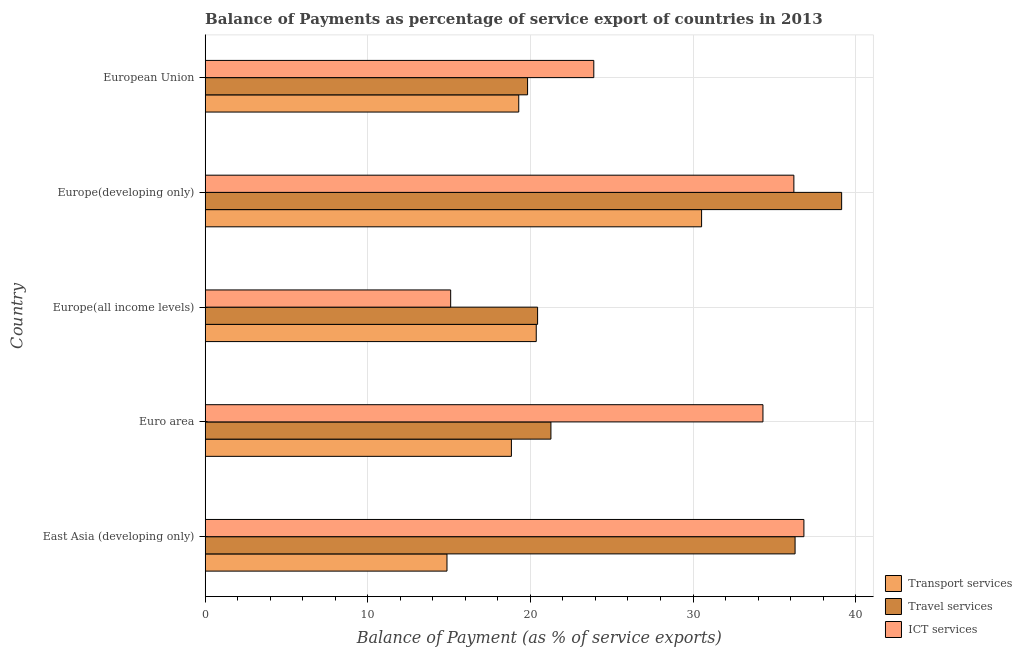Are the number of bars on each tick of the Y-axis equal?
Ensure brevity in your answer.  Yes. How many bars are there on the 1st tick from the top?
Make the answer very short. 3. How many bars are there on the 5th tick from the bottom?
Give a very brief answer. 3. What is the label of the 1st group of bars from the top?
Your answer should be very brief. European Union. What is the balance of payment of ict services in Europe(all income levels)?
Make the answer very short. 15.1. Across all countries, what is the maximum balance of payment of travel services?
Your response must be concise. 39.14. Across all countries, what is the minimum balance of payment of ict services?
Provide a succinct answer. 15.1. In which country was the balance of payment of ict services maximum?
Your response must be concise. East Asia (developing only). In which country was the balance of payment of travel services minimum?
Give a very brief answer. European Union. What is the total balance of payment of ict services in the graph?
Make the answer very short. 146.32. What is the difference between the balance of payment of ict services in Europe(developing only) and that in European Union?
Make the answer very short. 12.3. What is the difference between the balance of payment of travel services in Europe(all income levels) and the balance of payment of ict services in East Asia (developing only)?
Give a very brief answer. -16.38. What is the average balance of payment of ict services per country?
Provide a short and direct response. 29.26. What is the difference between the balance of payment of ict services and balance of payment of travel services in European Union?
Your response must be concise. 4.07. What is the ratio of the balance of payment of ict services in Euro area to that in Europe(developing only)?
Ensure brevity in your answer.  0.95. Is the difference between the balance of payment of ict services in East Asia (developing only) and Euro area greater than the difference between the balance of payment of travel services in East Asia (developing only) and Euro area?
Give a very brief answer. No. What is the difference between the highest and the second highest balance of payment of transport services?
Give a very brief answer. 10.17. What is the difference between the highest and the lowest balance of payment of ict services?
Provide a succinct answer. 21.72. In how many countries, is the balance of payment of ict services greater than the average balance of payment of ict services taken over all countries?
Your answer should be compact. 3. Is the sum of the balance of payment of ict services in East Asia (developing only) and Europe(developing only) greater than the maximum balance of payment of travel services across all countries?
Your answer should be very brief. Yes. What does the 1st bar from the top in East Asia (developing only) represents?
Offer a very short reply. ICT services. What does the 2nd bar from the bottom in European Union represents?
Your answer should be compact. Travel services. Is it the case that in every country, the sum of the balance of payment of transport services and balance of payment of travel services is greater than the balance of payment of ict services?
Your response must be concise. Yes. Are all the bars in the graph horizontal?
Provide a succinct answer. Yes. What is the difference between two consecutive major ticks on the X-axis?
Ensure brevity in your answer.  10. Where does the legend appear in the graph?
Your answer should be compact. Bottom right. How many legend labels are there?
Provide a short and direct response. 3. What is the title of the graph?
Provide a short and direct response. Balance of Payments as percentage of service export of countries in 2013. What is the label or title of the X-axis?
Provide a short and direct response. Balance of Payment (as % of service exports). What is the label or title of the Y-axis?
Offer a terse response. Country. What is the Balance of Payment (as % of service exports) in Transport services in East Asia (developing only)?
Your answer should be compact. 14.87. What is the Balance of Payment (as % of service exports) of Travel services in East Asia (developing only)?
Provide a short and direct response. 36.28. What is the Balance of Payment (as % of service exports) in ICT services in East Asia (developing only)?
Your response must be concise. 36.82. What is the Balance of Payment (as % of service exports) in Transport services in Euro area?
Give a very brief answer. 18.83. What is the Balance of Payment (as % of service exports) in Travel services in Euro area?
Provide a succinct answer. 21.26. What is the Balance of Payment (as % of service exports) in ICT services in Euro area?
Your answer should be very brief. 34.3. What is the Balance of Payment (as % of service exports) in Transport services in Europe(all income levels)?
Ensure brevity in your answer.  20.36. What is the Balance of Payment (as % of service exports) in Travel services in Europe(all income levels)?
Provide a succinct answer. 20.44. What is the Balance of Payment (as % of service exports) in ICT services in Europe(all income levels)?
Offer a very short reply. 15.1. What is the Balance of Payment (as % of service exports) in Transport services in Europe(developing only)?
Offer a terse response. 30.53. What is the Balance of Payment (as % of service exports) of Travel services in Europe(developing only)?
Offer a very short reply. 39.14. What is the Balance of Payment (as % of service exports) of ICT services in Europe(developing only)?
Provide a succinct answer. 36.2. What is the Balance of Payment (as % of service exports) of Transport services in European Union?
Provide a succinct answer. 19.28. What is the Balance of Payment (as % of service exports) of Travel services in European Union?
Provide a short and direct response. 19.83. What is the Balance of Payment (as % of service exports) in ICT services in European Union?
Make the answer very short. 23.9. Across all countries, what is the maximum Balance of Payment (as % of service exports) in Transport services?
Provide a short and direct response. 30.53. Across all countries, what is the maximum Balance of Payment (as % of service exports) of Travel services?
Your response must be concise. 39.14. Across all countries, what is the maximum Balance of Payment (as % of service exports) of ICT services?
Provide a short and direct response. 36.82. Across all countries, what is the minimum Balance of Payment (as % of service exports) in Transport services?
Give a very brief answer. 14.87. Across all countries, what is the minimum Balance of Payment (as % of service exports) in Travel services?
Your answer should be compact. 19.83. Across all countries, what is the minimum Balance of Payment (as % of service exports) of ICT services?
Your response must be concise. 15.1. What is the total Balance of Payment (as % of service exports) in Transport services in the graph?
Your response must be concise. 103.87. What is the total Balance of Payment (as % of service exports) of Travel services in the graph?
Offer a terse response. 136.95. What is the total Balance of Payment (as % of service exports) of ICT services in the graph?
Make the answer very short. 146.32. What is the difference between the Balance of Payment (as % of service exports) of Transport services in East Asia (developing only) and that in Euro area?
Provide a short and direct response. -3.96. What is the difference between the Balance of Payment (as % of service exports) in Travel services in East Asia (developing only) and that in Euro area?
Keep it short and to the point. 15.02. What is the difference between the Balance of Payment (as % of service exports) of ICT services in East Asia (developing only) and that in Euro area?
Ensure brevity in your answer.  2.52. What is the difference between the Balance of Payment (as % of service exports) of Transport services in East Asia (developing only) and that in Europe(all income levels)?
Make the answer very short. -5.49. What is the difference between the Balance of Payment (as % of service exports) of Travel services in East Asia (developing only) and that in Europe(all income levels)?
Offer a very short reply. 15.83. What is the difference between the Balance of Payment (as % of service exports) in ICT services in East Asia (developing only) and that in Europe(all income levels)?
Ensure brevity in your answer.  21.72. What is the difference between the Balance of Payment (as % of service exports) in Transport services in East Asia (developing only) and that in Europe(developing only)?
Provide a succinct answer. -15.66. What is the difference between the Balance of Payment (as % of service exports) of Travel services in East Asia (developing only) and that in Europe(developing only)?
Offer a terse response. -2.86. What is the difference between the Balance of Payment (as % of service exports) of ICT services in East Asia (developing only) and that in Europe(developing only)?
Give a very brief answer. 0.62. What is the difference between the Balance of Payment (as % of service exports) of Transport services in East Asia (developing only) and that in European Union?
Keep it short and to the point. -4.41. What is the difference between the Balance of Payment (as % of service exports) of Travel services in East Asia (developing only) and that in European Union?
Provide a short and direct response. 16.45. What is the difference between the Balance of Payment (as % of service exports) in ICT services in East Asia (developing only) and that in European Union?
Keep it short and to the point. 12.92. What is the difference between the Balance of Payment (as % of service exports) of Transport services in Euro area and that in Europe(all income levels)?
Your answer should be compact. -1.53. What is the difference between the Balance of Payment (as % of service exports) of Travel services in Euro area and that in Europe(all income levels)?
Provide a short and direct response. 0.82. What is the difference between the Balance of Payment (as % of service exports) in ICT services in Euro area and that in Europe(all income levels)?
Provide a short and direct response. 19.2. What is the difference between the Balance of Payment (as % of service exports) of Transport services in Euro area and that in Europe(developing only)?
Keep it short and to the point. -11.7. What is the difference between the Balance of Payment (as % of service exports) in Travel services in Euro area and that in Europe(developing only)?
Ensure brevity in your answer.  -17.88. What is the difference between the Balance of Payment (as % of service exports) of ICT services in Euro area and that in Europe(developing only)?
Ensure brevity in your answer.  -1.9. What is the difference between the Balance of Payment (as % of service exports) of Transport services in Euro area and that in European Union?
Make the answer very short. -0.45. What is the difference between the Balance of Payment (as % of service exports) of Travel services in Euro area and that in European Union?
Ensure brevity in your answer.  1.44. What is the difference between the Balance of Payment (as % of service exports) in ICT services in Euro area and that in European Union?
Keep it short and to the point. 10.4. What is the difference between the Balance of Payment (as % of service exports) in Transport services in Europe(all income levels) and that in Europe(developing only)?
Keep it short and to the point. -10.17. What is the difference between the Balance of Payment (as % of service exports) of Travel services in Europe(all income levels) and that in Europe(developing only)?
Keep it short and to the point. -18.7. What is the difference between the Balance of Payment (as % of service exports) in ICT services in Europe(all income levels) and that in Europe(developing only)?
Your response must be concise. -21.11. What is the difference between the Balance of Payment (as % of service exports) in Transport services in Europe(all income levels) and that in European Union?
Offer a very short reply. 1.08. What is the difference between the Balance of Payment (as % of service exports) in Travel services in Europe(all income levels) and that in European Union?
Keep it short and to the point. 0.62. What is the difference between the Balance of Payment (as % of service exports) of ICT services in Europe(all income levels) and that in European Union?
Offer a very short reply. -8.8. What is the difference between the Balance of Payment (as % of service exports) in Transport services in Europe(developing only) and that in European Union?
Offer a terse response. 11.24. What is the difference between the Balance of Payment (as % of service exports) of Travel services in Europe(developing only) and that in European Union?
Keep it short and to the point. 19.31. What is the difference between the Balance of Payment (as % of service exports) of ICT services in Europe(developing only) and that in European Union?
Ensure brevity in your answer.  12.3. What is the difference between the Balance of Payment (as % of service exports) of Transport services in East Asia (developing only) and the Balance of Payment (as % of service exports) of Travel services in Euro area?
Provide a succinct answer. -6.39. What is the difference between the Balance of Payment (as % of service exports) in Transport services in East Asia (developing only) and the Balance of Payment (as % of service exports) in ICT services in Euro area?
Offer a very short reply. -19.43. What is the difference between the Balance of Payment (as % of service exports) in Travel services in East Asia (developing only) and the Balance of Payment (as % of service exports) in ICT services in Euro area?
Your response must be concise. 1.98. What is the difference between the Balance of Payment (as % of service exports) in Transport services in East Asia (developing only) and the Balance of Payment (as % of service exports) in Travel services in Europe(all income levels)?
Make the answer very short. -5.57. What is the difference between the Balance of Payment (as % of service exports) of Transport services in East Asia (developing only) and the Balance of Payment (as % of service exports) of ICT services in Europe(all income levels)?
Your answer should be very brief. -0.23. What is the difference between the Balance of Payment (as % of service exports) in Travel services in East Asia (developing only) and the Balance of Payment (as % of service exports) in ICT services in Europe(all income levels)?
Your response must be concise. 21.18. What is the difference between the Balance of Payment (as % of service exports) in Transport services in East Asia (developing only) and the Balance of Payment (as % of service exports) in Travel services in Europe(developing only)?
Offer a terse response. -24.27. What is the difference between the Balance of Payment (as % of service exports) in Transport services in East Asia (developing only) and the Balance of Payment (as % of service exports) in ICT services in Europe(developing only)?
Keep it short and to the point. -21.33. What is the difference between the Balance of Payment (as % of service exports) in Travel services in East Asia (developing only) and the Balance of Payment (as % of service exports) in ICT services in Europe(developing only)?
Offer a very short reply. 0.07. What is the difference between the Balance of Payment (as % of service exports) of Transport services in East Asia (developing only) and the Balance of Payment (as % of service exports) of Travel services in European Union?
Give a very brief answer. -4.96. What is the difference between the Balance of Payment (as % of service exports) of Transport services in East Asia (developing only) and the Balance of Payment (as % of service exports) of ICT services in European Union?
Ensure brevity in your answer.  -9.03. What is the difference between the Balance of Payment (as % of service exports) of Travel services in East Asia (developing only) and the Balance of Payment (as % of service exports) of ICT services in European Union?
Provide a succinct answer. 12.38. What is the difference between the Balance of Payment (as % of service exports) in Transport services in Euro area and the Balance of Payment (as % of service exports) in Travel services in Europe(all income levels)?
Provide a short and direct response. -1.61. What is the difference between the Balance of Payment (as % of service exports) in Transport services in Euro area and the Balance of Payment (as % of service exports) in ICT services in Europe(all income levels)?
Make the answer very short. 3.73. What is the difference between the Balance of Payment (as % of service exports) in Travel services in Euro area and the Balance of Payment (as % of service exports) in ICT services in Europe(all income levels)?
Your answer should be very brief. 6.17. What is the difference between the Balance of Payment (as % of service exports) in Transport services in Euro area and the Balance of Payment (as % of service exports) in Travel services in Europe(developing only)?
Make the answer very short. -20.31. What is the difference between the Balance of Payment (as % of service exports) of Transport services in Euro area and the Balance of Payment (as % of service exports) of ICT services in Europe(developing only)?
Your response must be concise. -17.37. What is the difference between the Balance of Payment (as % of service exports) of Travel services in Euro area and the Balance of Payment (as % of service exports) of ICT services in Europe(developing only)?
Make the answer very short. -14.94. What is the difference between the Balance of Payment (as % of service exports) of Transport services in Euro area and the Balance of Payment (as % of service exports) of Travel services in European Union?
Offer a terse response. -0.99. What is the difference between the Balance of Payment (as % of service exports) in Transport services in Euro area and the Balance of Payment (as % of service exports) in ICT services in European Union?
Ensure brevity in your answer.  -5.07. What is the difference between the Balance of Payment (as % of service exports) of Travel services in Euro area and the Balance of Payment (as % of service exports) of ICT services in European Union?
Provide a succinct answer. -2.64. What is the difference between the Balance of Payment (as % of service exports) in Transport services in Europe(all income levels) and the Balance of Payment (as % of service exports) in Travel services in Europe(developing only)?
Your answer should be very brief. -18.78. What is the difference between the Balance of Payment (as % of service exports) of Transport services in Europe(all income levels) and the Balance of Payment (as % of service exports) of ICT services in Europe(developing only)?
Offer a very short reply. -15.84. What is the difference between the Balance of Payment (as % of service exports) in Travel services in Europe(all income levels) and the Balance of Payment (as % of service exports) in ICT services in Europe(developing only)?
Offer a very short reply. -15.76. What is the difference between the Balance of Payment (as % of service exports) of Transport services in Europe(all income levels) and the Balance of Payment (as % of service exports) of Travel services in European Union?
Provide a short and direct response. 0.53. What is the difference between the Balance of Payment (as % of service exports) of Transport services in Europe(all income levels) and the Balance of Payment (as % of service exports) of ICT services in European Union?
Give a very brief answer. -3.54. What is the difference between the Balance of Payment (as % of service exports) of Travel services in Europe(all income levels) and the Balance of Payment (as % of service exports) of ICT services in European Union?
Your response must be concise. -3.46. What is the difference between the Balance of Payment (as % of service exports) of Transport services in Europe(developing only) and the Balance of Payment (as % of service exports) of Travel services in European Union?
Your answer should be very brief. 10.7. What is the difference between the Balance of Payment (as % of service exports) in Transport services in Europe(developing only) and the Balance of Payment (as % of service exports) in ICT services in European Union?
Ensure brevity in your answer.  6.63. What is the difference between the Balance of Payment (as % of service exports) in Travel services in Europe(developing only) and the Balance of Payment (as % of service exports) in ICT services in European Union?
Your response must be concise. 15.24. What is the average Balance of Payment (as % of service exports) of Transport services per country?
Offer a very short reply. 20.77. What is the average Balance of Payment (as % of service exports) in Travel services per country?
Give a very brief answer. 27.39. What is the average Balance of Payment (as % of service exports) in ICT services per country?
Offer a terse response. 29.26. What is the difference between the Balance of Payment (as % of service exports) in Transport services and Balance of Payment (as % of service exports) in Travel services in East Asia (developing only)?
Give a very brief answer. -21.41. What is the difference between the Balance of Payment (as % of service exports) in Transport services and Balance of Payment (as % of service exports) in ICT services in East Asia (developing only)?
Provide a succinct answer. -21.95. What is the difference between the Balance of Payment (as % of service exports) in Travel services and Balance of Payment (as % of service exports) in ICT services in East Asia (developing only)?
Offer a very short reply. -0.54. What is the difference between the Balance of Payment (as % of service exports) in Transport services and Balance of Payment (as % of service exports) in Travel services in Euro area?
Keep it short and to the point. -2.43. What is the difference between the Balance of Payment (as % of service exports) in Transport services and Balance of Payment (as % of service exports) in ICT services in Euro area?
Your response must be concise. -15.47. What is the difference between the Balance of Payment (as % of service exports) of Travel services and Balance of Payment (as % of service exports) of ICT services in Euro area?
Your answer should be compact. -13.04. What is the difference between the Balance of Payment (as % of service exports) of Transport services and Balance of Payment (as % of service exports) of Travel services in Europe(all income levels)?
Offer a very short reply. -0.08. What is the difference between the Balance of Payment (as % of service exports) of Transport services and Balance of Payment (as % of service exports) of ICT services in Europe(all income levels)?
Make the answer very short. 5.26. What is the difference between the Balance of Payment (as % of service exports) in Travel services and Balance of Payment (as % of service exports) in ICT services in Europe(all income levels)?
Make the answer very short. 5.35. What is the difference between the Balance of Payment (as % of service exports) in Transport services and Balance of Payment (as % of service exports) in Travel services in Europe(developing only)?
Your response must be concise. -8.61. What is the difference between the Balance of Payment (as % of service exports) in Transport services and Balance of Payment (as % of service exports) in ICT services in Europe(developing only)?
Give a very brief answer. -5.68. What is the difference between the Balance of Payment (as % of service exports) in Travel services and Balance of Payment (as % of service exports) in ICT services in Europe(developing only)?
Make the answer very short. 2.94. What is the difference between the Balance of Payment (as % of service exports) in Transport services and Balance of Payment (as % of service exports) in Travel services in European Union?
Offer a terse response. -0.54. What is the difference between the Balance of Payment (as % of service exports) in Transport services and Balance of Payment (as % of service exports) in ICT services in European Union?
Give a very brief answer. -4.62. What is the difference between the Balance of Payment (as % of service exports) in Travel services and Balance of Payment (as % of service exports) in ICT services in European Union?
Offer a terse response. -4.07. What is the ratio of the Balance of Payment (as % of service exports) of Transport services in East Asia (developing only) to that in Euro area?
Your answer should be very brief. 0.79. What is the ratio of the Balance of Payment (as % of service exports) in Travel services in East Asia (developing only) to that in Euro area?
Keep it short and to the point. 1.71. What is the ratio of the Balance of Payment (as % of service exports) in ICT services in East Asia (developing only) to that in Euro area?
Offer a terse response. 1.07. What is the ratio of the Balance of Payment (as % of service exports) of Transport services in East Asia (developing only) to that in Europe(all income levels)?
Your response must be concise. 0.73. What is the ratio of the Balance of Payment (as % of service exports) of Travel services in East Asia (developing only) to that in Europe(all income levels)?
Offer a terse response. 1.77. What is the ratio of the Balance of Payment (as % of service exports) of ICT services in East Asia (developing only) to that in Europe(all income levels)?
Keep it short and to the point. 2.44. What is the ratio of the Balance of Payment (as % of service exports) in Transport services in East Asia (developing only) to that in Europe(developing only)?
Make the answer very short. 0.49. What is the ratio of the Balance of Payment (as % of service exports) of Travel services in East Asia (developing only) to that in Europe(developing only)?
Provide a succinct answer. 0.93. What is the ratio of the Balance of Payment (as % of service exports) in ICT services in East Asia (developing only) to that in Europe(developing only)?
Ensure brevity in your answer.  1.02. What is the ratio of the Balance of Payment (as % of service exports) in Transport services in East Asia (developing only) to that in European Union?
Give a very brief answer. 0.77. What is the ratio of the Balance of Payment (as % of service exports) in Travel services in East Asia (developing only) to that in European Union?
Make the answer very short. 1.83. What is the ratio of the Balance of Payment (as % of service exports) of ICT services in East Asia (developing only) to that in European Union?
Give a very brief answer. 1.54. What is the ratio of the Balance of Payment (as % of service exports) in Transport services in Euro area to that in Europe(all income levels)?
Provide a short and direct response. 0.93. What is the ratio of the Balance of Payment (as % of service exports) of Travel services in Euro area to that in Europe(all income levels)?
Keep it short and to the point. 1.04. What is the ratio of the Balance of Payment (as % of service exports) of ICT services in Euro area to that in Europe(all income levels)?
Your answer should be very brief. 2.27. What is the ratio of the Balance of Payment (as % of service exports) of Transport services in Euro area to that in Europe(developing only)?
Offer a terse response. 0.62. What is the ratio of the Balance of Payment (as % of service exports) of Travel services in Euro area to that in Europe(developing only)?
Your answer should be compact. 0.54. What is the ratio of the Balance of Payment (as % of service exports) in ICT services in Euro area to that in Europe(developing only)?
Your answer should be very brief. 0.95. What is the ratio of the Balance of Payment (as % of service exports) in Transport services in Euro area to that in European Union?
Offer a terse response. 0.98. What is the ratio of the Balance of Payment (as % of service exports) of Travel services in Euro area to that in European Union?
Offer a very short reply. 1.07. What is the ratio of the Balance of Payment (as % of service exports) in ICT services in Euro area to that in European Union?
Provide a short and direct response. 1.44. What is the ratio of the Balance of Payment (as % of service exports) of Transport services in Europe(all income levels) to that in Europe(developing only)?
Offer a terse response. 0.67. What is the ratio of the Balance of Payment (as % of service exports) of Travel services in Europe(all income levels) to that in Europe(developing only)?
Ensure brevity in your answer.  0.52. What is the ratio of the Balance of Payment (as % of service exports) of ICT services in Europe(all income levels) to that in Europe(developing only)?
Your answer should be very brief. 0.42. What is the ratio of the Balance of Payment (as % of service exports) in Transport services in Europe(all income levels) to that in European Union?
Ensure brevity in your answer.  1.06. What is the ratio of the Balance of Payment (as % of service exports) of Travel services in Europe(all income levels) to that in European Union?
Make the answer very short. 1.03. What is the ratio of the Balance of Payment (as % of service exports) in ICT services in Europe(all income levels) to that in European Union?
Ensure brevity in your answer.  0.63. What is the ratio of the Balance of Payment (as % of service exports) of Transport services in Europe(developing only) to that in European Union?
Your answer should be very brief. 1.58. What is the ratio of the Balance of Payment (as % of service exports) in Travel services in Europe(developing only) to that in European Union?
Make the answer very short. 1.97. What is the ratio of the Balance of Payment (as % of service exports) of ICT services in Europe(developing only) to that in European Union?
Give a very brief answer. 1.51. What is the difference between the highest and the second highest Balance of Payment (as % of service exports) in Transport services?
Offer a very short reply. 10.17. What is the difference between the highest and the second highest Balance of Payment (as % of service exports) in Travel services?
Provide a short and direct response. 2.86. What is the difference between the highest and the second highest Balance of Payment (as % of service exports) in ICT services?
Your answer should be very brief. 0.62. What is the difference between the highest and the lowest Balance of Payment (as % of service exports) in Transport services?
Offer a terse response. 15.66. What is the difference between the highest and the lowest Balance of Payment (as % of service exports) of Travel services?
Provide a succinct answer. 19.31. What is the difference between the highest and the lowest Balance of Payment (as % of service exports) in ICT services?
Offer a terse response. 21.72. 